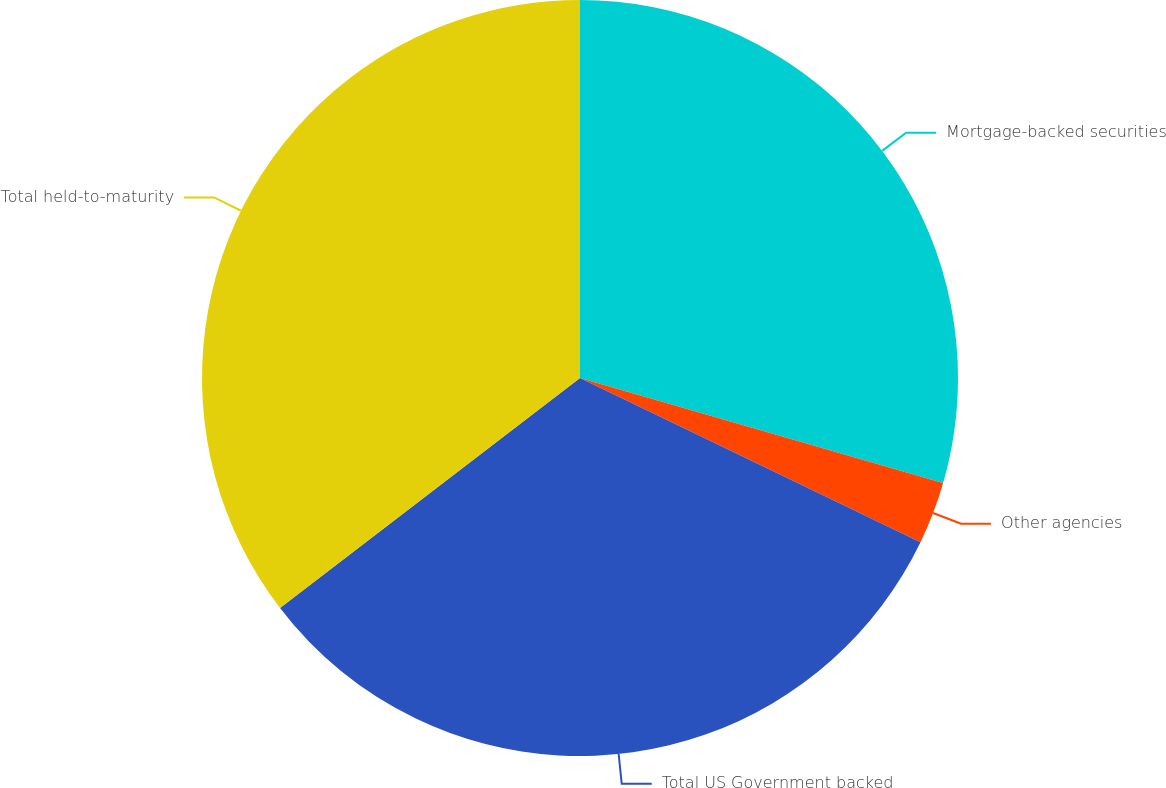Convert chart. <chart><loc_0><loc_0><loc_500><loc_500><pie_chart><fcel>Mortgage-backed securities<fcel>Other agencies<fcel>Total US Government backed<fcel>Total held-to-maturity<nl><fcel>29.48%<fcel>2.67%<fcel>32.44%<fcel>35.41%<nl></chart> 